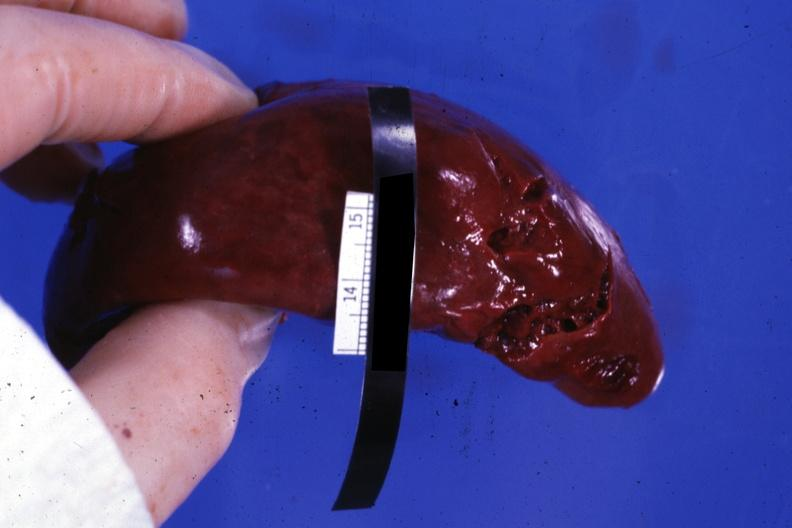what is present?
Answer the question using a single word or phrase. Hematologic 